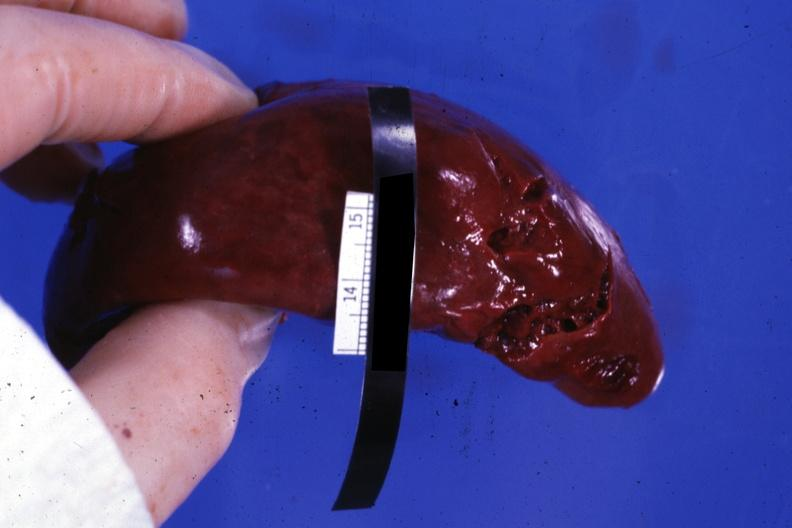what is present?
Answer the question using a single word or phrase. Hematologic 